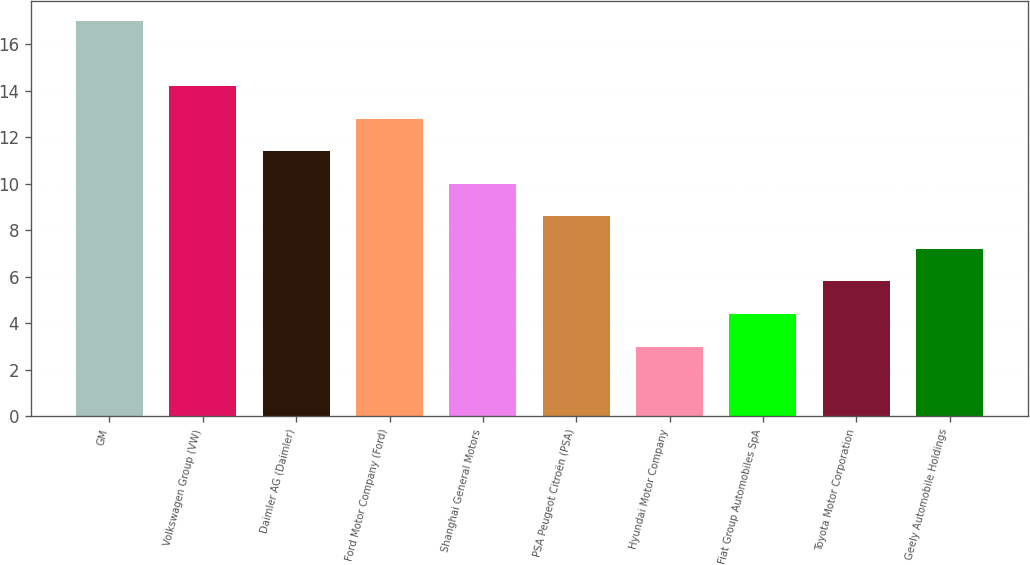<chart> <loc_0><loc_0><loc_500><loc_500><bar_chart><fcel>GM<fcel>Volkswagen Group (VW)<fcel>Daimler AG (Daimler)<fcel>Ford Motor Company (Ford)<fcel>Shanghai General Motors<fcel>PSA Peugeot Citroën (PSA)<fcel>Hyundai Motor Company<fcel>Fiat Group Automobiles SpA<fcel>Toyota Motor Corporation<fcel>Geely Automobile Holdings<nl><fcel>17<fcel>14.2<fcel>11.4<fcel>12.8<fcel>10<fcel>8.6<fcel>3<fcel>4.4<fcel>5.8<fcel>7.2<nl></chart> 